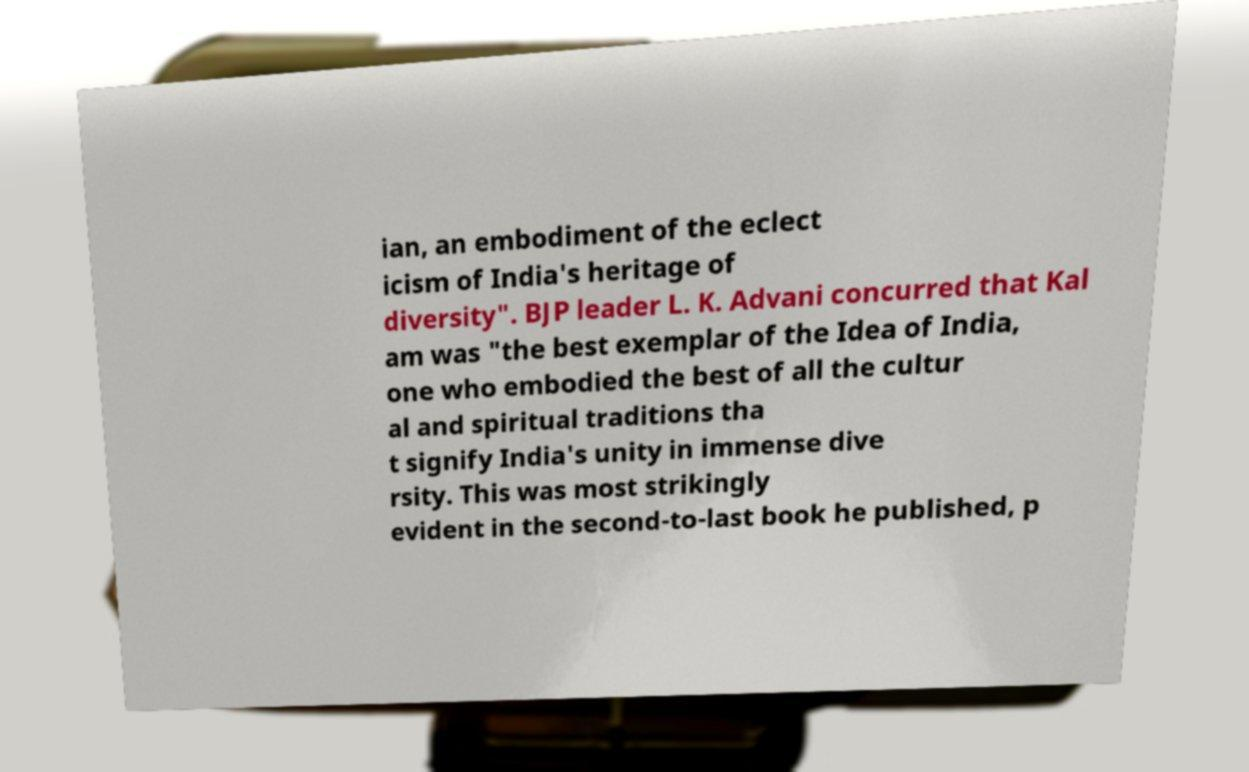For documentation purposes, I need the text within this image transcribed. Could you provide that? ian, an embodiment of the eclect icism of India's heritage of diversity". BJP leader L. K. Advani concurred that Kal am was "the best exemplar of the Idea of India, one who embodied the best of all the cultur al and spiritual traditions tha t signify India's unity in immense dive rsity. This was most strikingly evident in the second-to-last book he published, p 